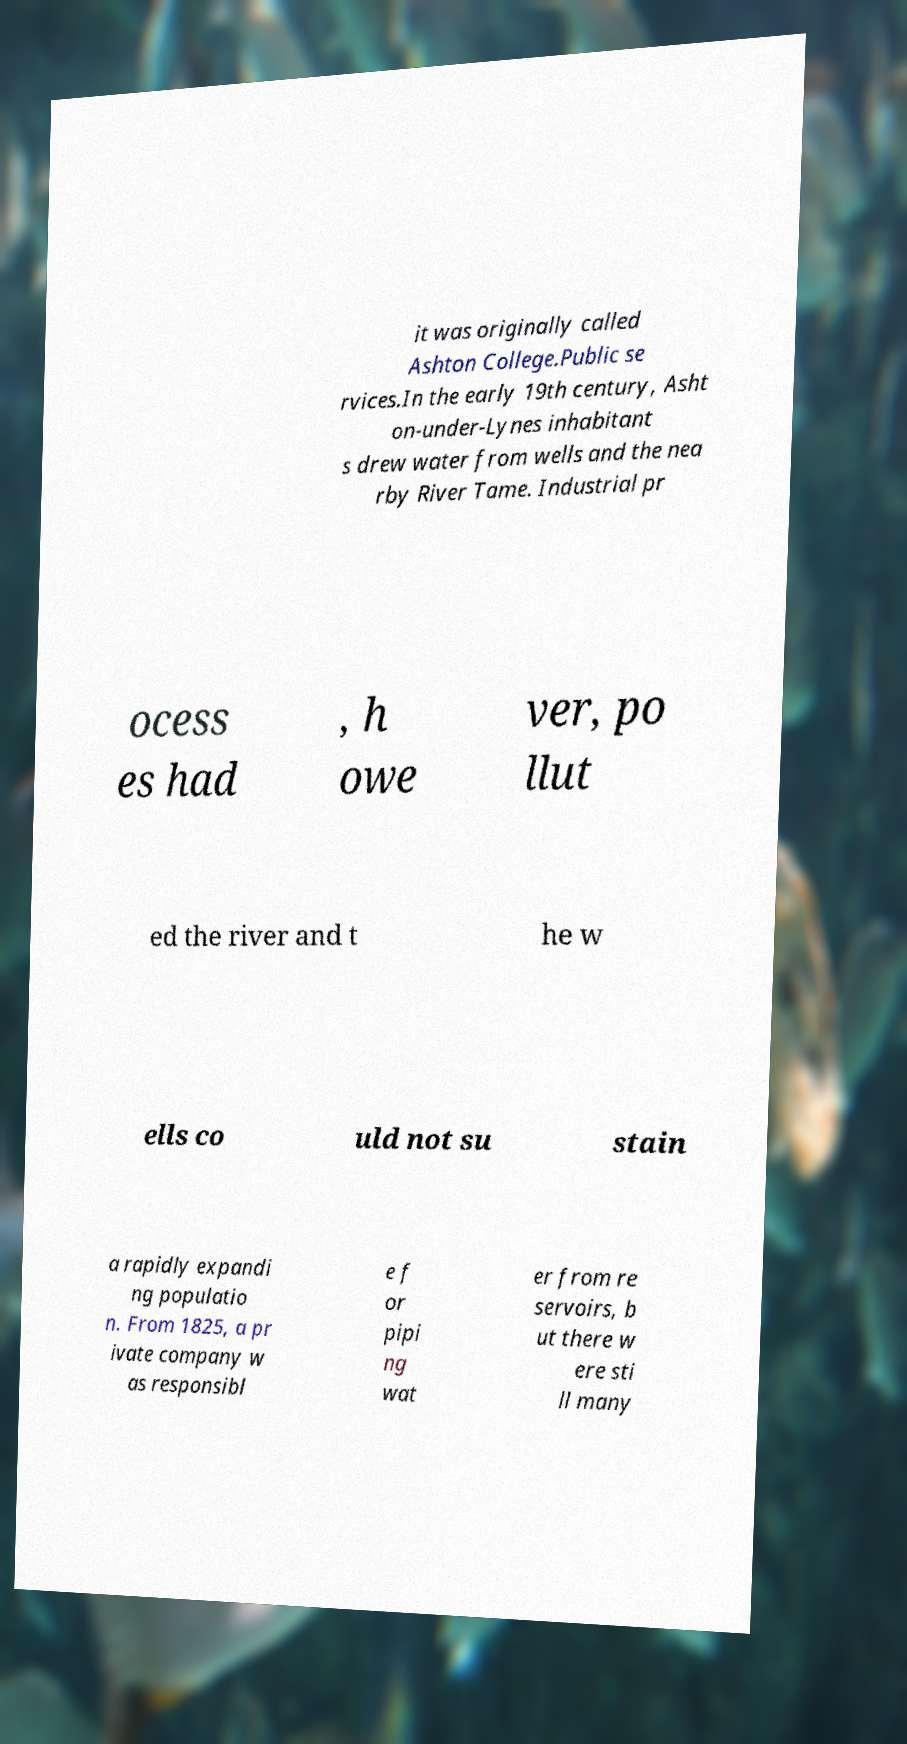Could you extract and type out the text from this image? it was originally called Ashton College.Public se rvices.In the early 19th century, Asht on-under-Lynes inhabitant s drew water from wells and the nea rby River Tame. Industrial pr ocess es had , h owe ver, po llut ed the river and t he w ells co uld not su stain a rapidly expandi ng populatio n. From 1825, a pr ivate company w as responsibl e f or pipi ng wat er from re servoirs, b ut there w ere sti ll many 